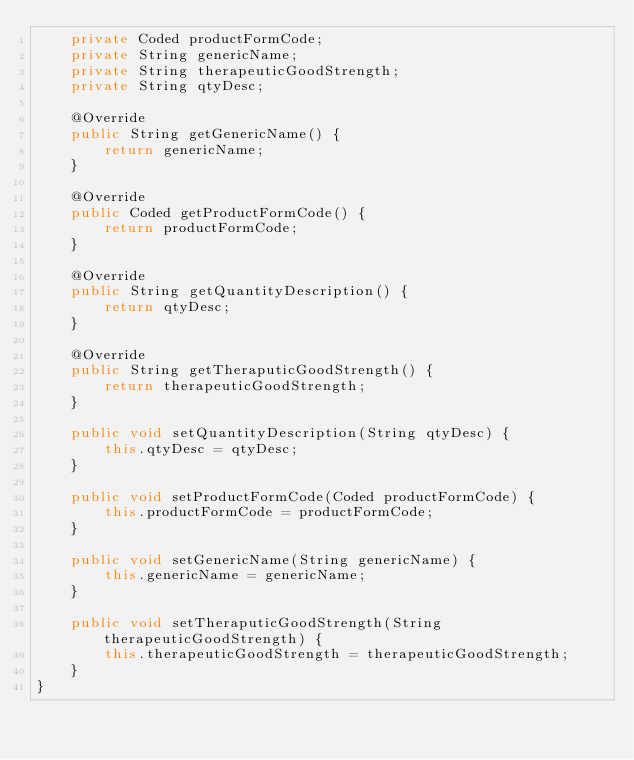<code> <loc_0><loc_0><loc_500><loc_500><_Java_>    private Coded productFormCode;
    private String genericName;
    private String therapeuticGoodStrength;
    private String qtyDesc;

    @Override
    public String getGenericName() {
        return genericName;
    }

    @Override
    public Coded getProductFormCode() {
        return productFormCode;
    }

    @Override
    public String getQuantityDescription() {
        return qtyDesc;
    }

    @Override
    public String getTheraputicGoodStrength() {
        return therapeuticGoodStrength;
    }

    public void setQuantityDescription(String qtyDesc) {
        this.qtyDesc = qtyDesc;
    }

    public void setProductFormCode(Coded productFormCode) {
        this.productFormCode = productFormCode;
    }

    public void setGenericName(String genericName) {
        this.genericName = genericName;
    }

    public void setTheraputicGoodStrength(String therapeuticGoodStrength) {
        this.therapeuticGoodStrength = therapeuticGoodStrength;
    }
}
</code> 